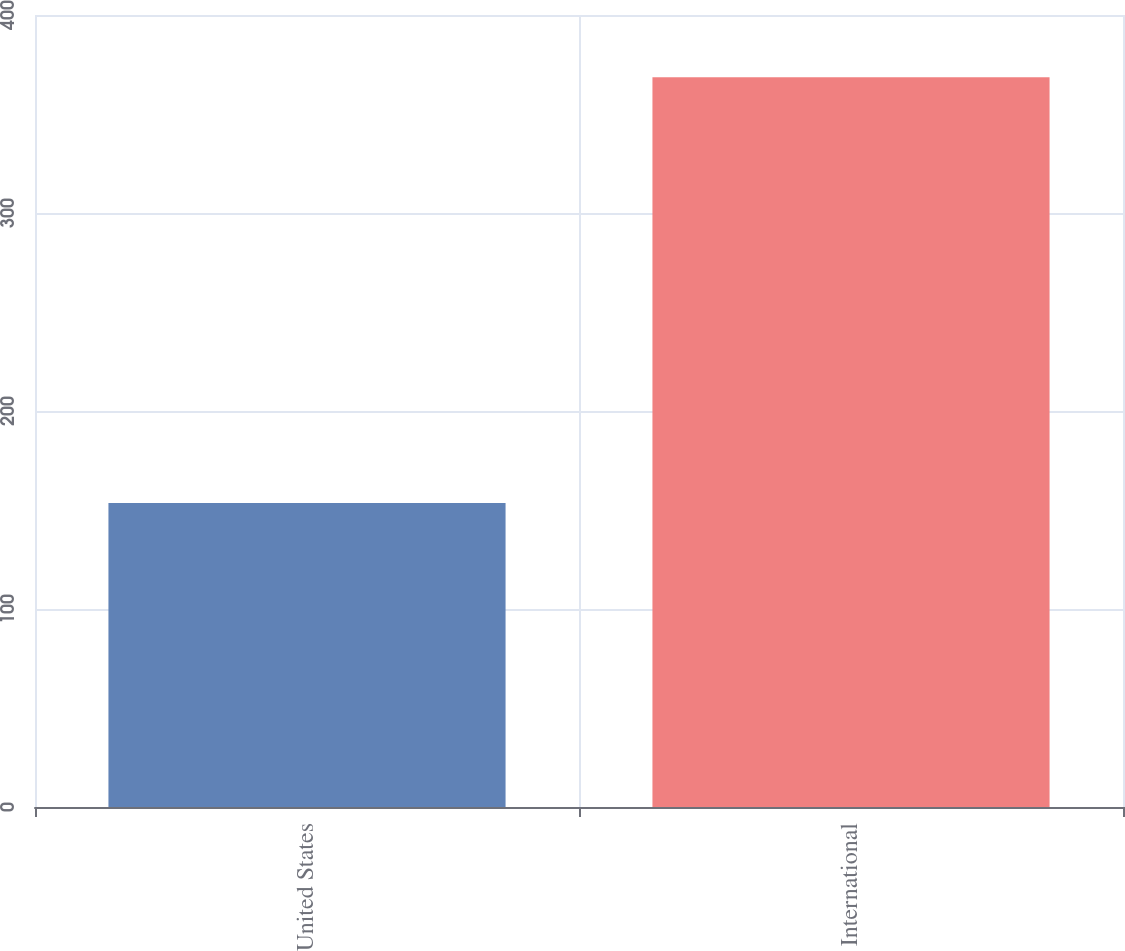Convert chart. <chart><loc_0><loc_0><loc_500><loc_500><bar_chart><fcel>United States<fcel>International<nl><fcel>153.5<fcel>368.6<nl></chart> 